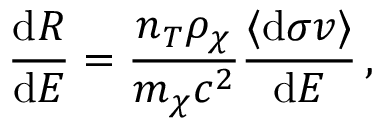<formula> <loc_0><loc_0><loc_500><loc_500>\frac { d R } { d E } = \frac { n _ { T } \rho _ { \chi } } { m _ { \chi } c ^ { 2 } } \frac { \langle d \sigma v \rangle } { d E } \, ,</formula> 